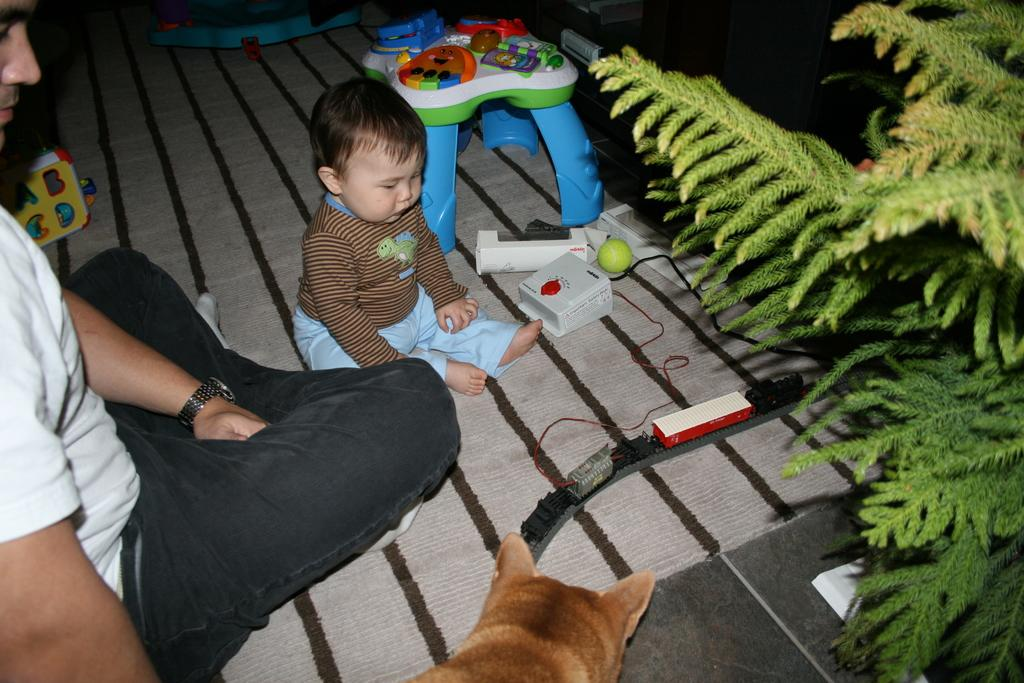Who is present in the image? There is a man in the image. What is the man wearing? The man is wearing a white t-shirt. Who else is present in the image? There is a child, a dog, and a toy in the image. What other objects can be seen in the image? There is a ball, a stool, and a tree in the image. What type of blade can be seen in the image? There is no blade present in the image. How does the image demonstrate improved acoustics? The image does not demonstrate improved acoustics, as it does not contain any elements related to sound or audio quality. 